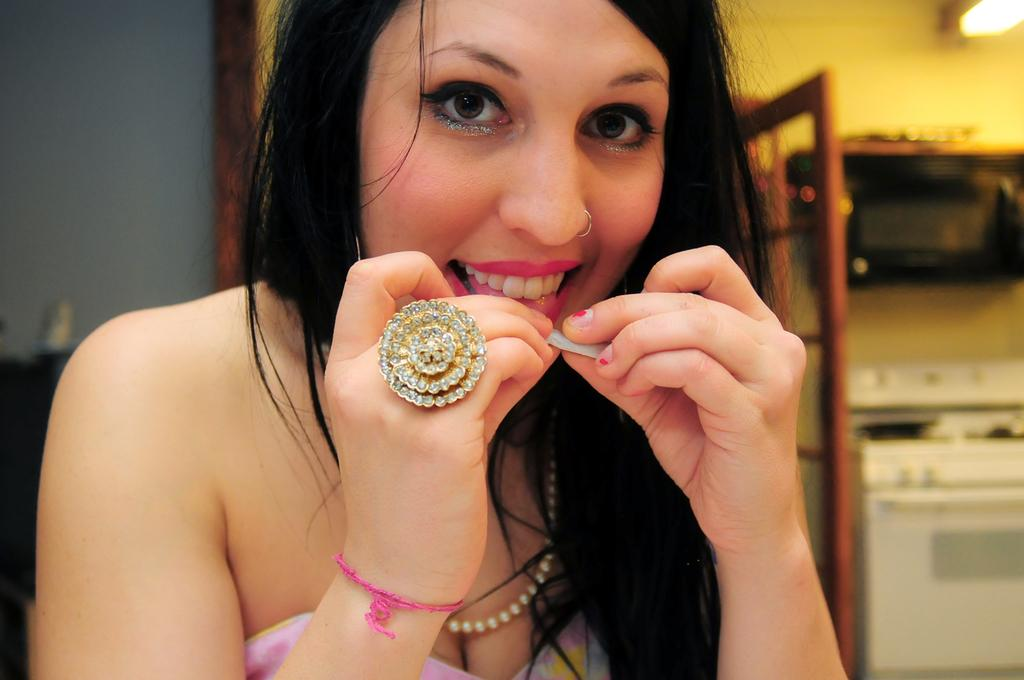Who is the main subject in the image? There is a lady in the image. What is the lady holding in the image? The lady is holding an object. What can be seen on the wall at the right side of the image? There is a lamp on the wall at the right side of the image. What other objects are present at the right side of the image? There are other objects present at the right side of the image. What degree does the creator of the lamp have? There is no information about the creator of the lamp in the image, nor is there any indication of their educational background. 